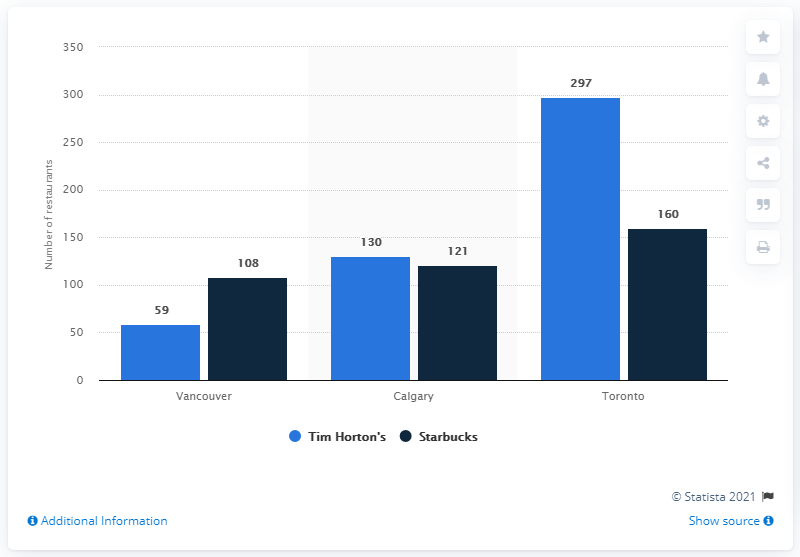How many Starbucks coffee houses were there in Vancouver in January 2015? As of the data provided in the chart from 2021, there were 108 Starbucks coffee houses in Vancouver. It's important to note that this number can fluctuate over time due to new openings, closures, or rebrandings. 